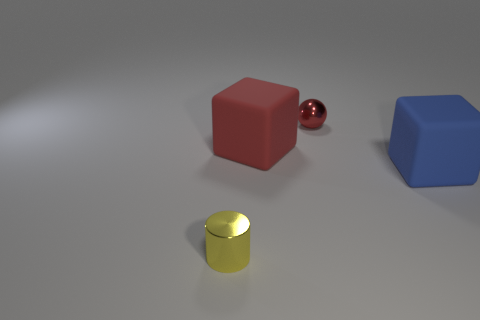Add 3 tiny red metallic cubes. How many objects exist? 7 Subtract all green cylinders. How many red cubes are left? 1 Subtract all big blue things. Subtract all large cyan matte balls. How many objects are left? 3 Add 2 metal things. How many metal things are left? 4 Add 2 large blue cubes. How many large blue cubes exist? 3 Subtract 0 blue spheres. How many objects are left? 4 Subtract all gray balls. Subtract all cyan blocks. How many balls are left? 1 